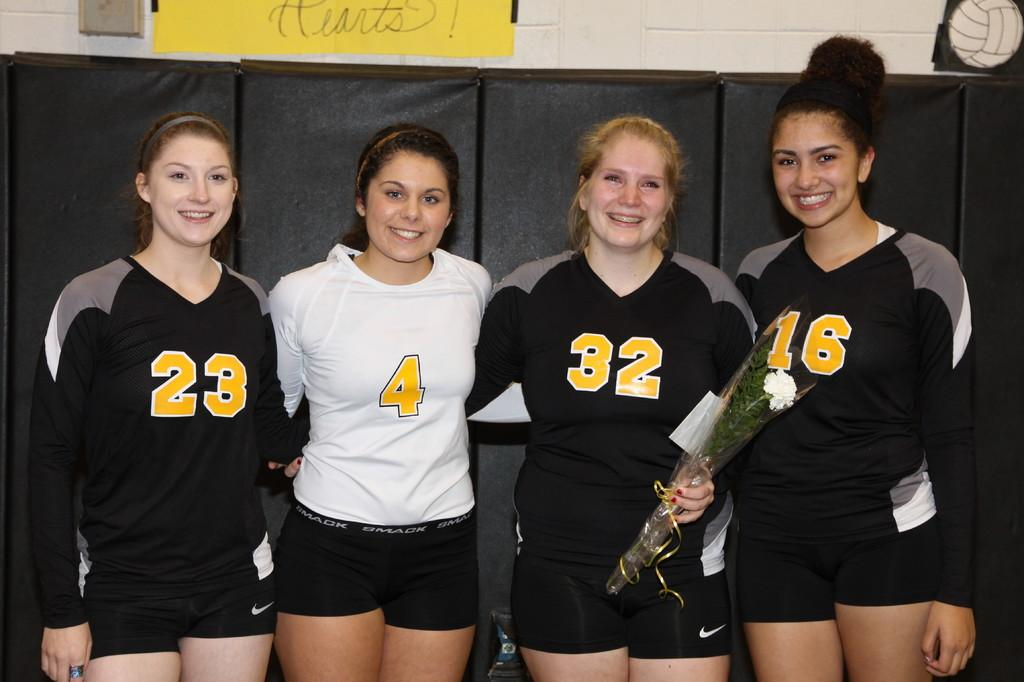<image>
Create a compact narrative representing the image presented. A group of 4 girls three in black shirts and one in a white shirt with the number 4 on it. 